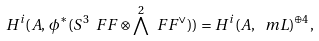<formula> <loc_0><loc_0><loc_500><loc_500>H ^ { i } ( A , \, \phi ^ { * } ( S ^ { 3 } \ F F \otimes \bigwedge ^ { 2 } \ F F ^ { \vee } ) ) = H ^ { i } ( A , \, \ m L ) ^ { \oplus 4 } ,</formula> 